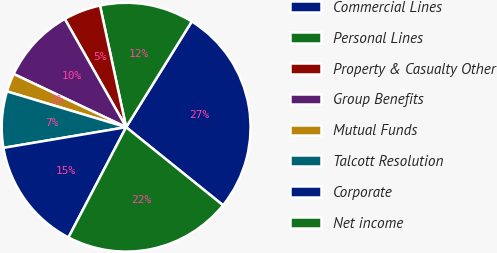Convert chart. <chart><loc_0><loc_0><loc_500><loc_500><pie_chart><fcel>Commercial Lines<fcel>Personal Lines<fcel>Property & Casualty Other<fcel>Group Benefits<fcel>Mutual Funds<fcel>Talcott Resolution<fcel>Corporate<fcel>Net income<nl><fcel>26.95%<fcel>12.21%<fcel>4.84%<fcel>9.76%<fcel>2.39%<fcel>7.3%<fcel>14.67%<fcel>21.88%<nl></chart> 